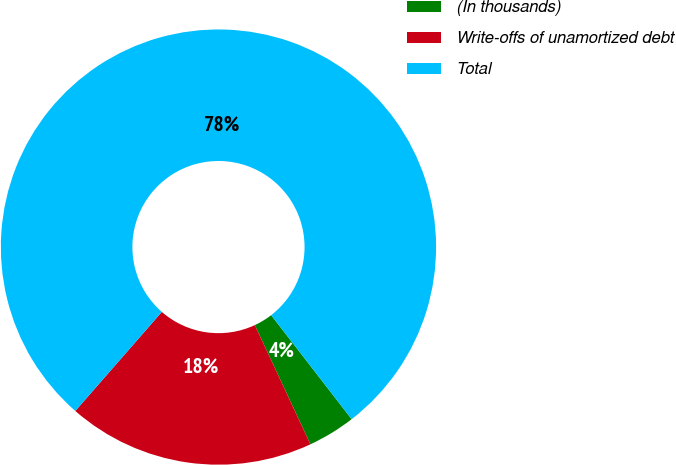<chart> <loc_0><loc_0><loc_500><loc_500><pie_chart><fcel>(In thousands)<fcel>Write-offs of unamortized debt<fcel>Total<nl><fcel>3.54%<fcel>18.37%<fcel>78.09%<nl></chart> 